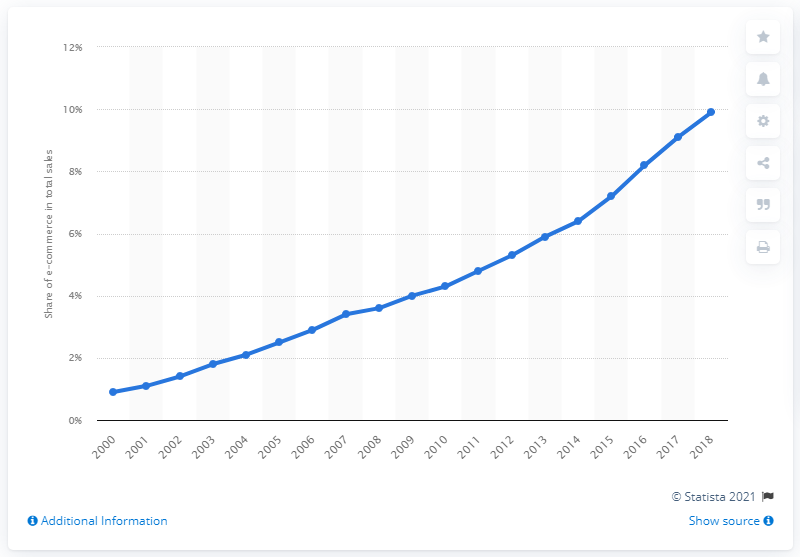Highlight a few significant elements in this photo. In the previous year, e-commerce accounted for 9.1% of total retail sales. In 2018, e-commerce accounted for 9.9% of total retail sales. 